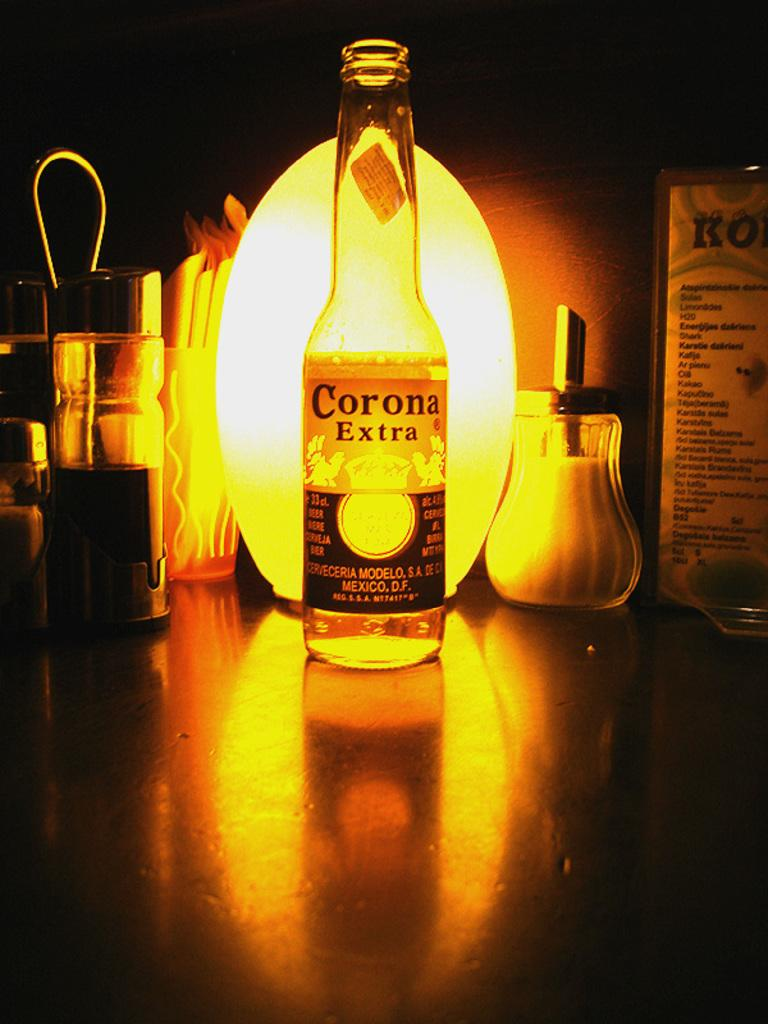What is on the bottle in the image? There is a sticker on the bottle in the image. What can be seen on the right side of the image? There is a card on the right side of the image. What type of objects are on the left side of the image? There are containers on the left side of the image. What type of list can be seen on the card in the image? There is no list present on the card in the image; it only shows a card. How many cushions are visible in the image? There are no cushions visible in the image. 